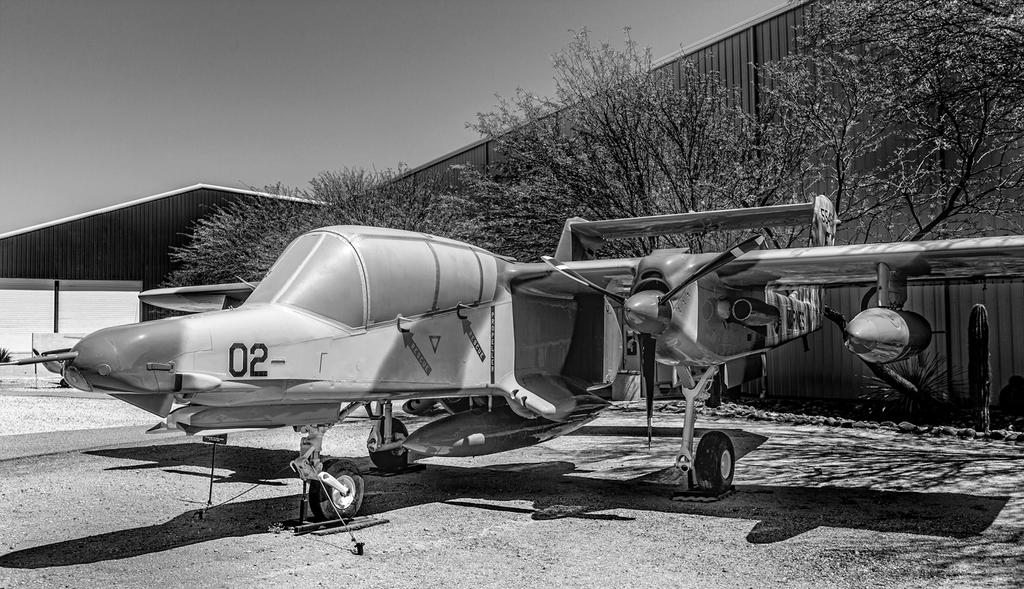Provide a one-sentence caption for the provided image. a small old plane with 02 on its nose sits near a hangar. 